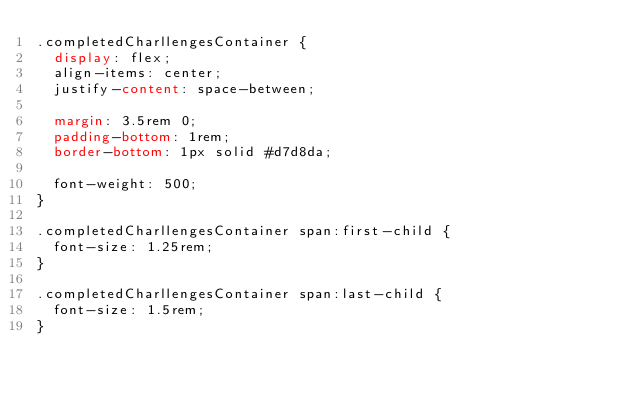Convert code to text. <code><loc_0><loc_0><loc_500><loc_500><_CSS_>.completedCharllengesContainer {
  display: flex;
  align-items: center;
  justify-content: space-between;

  margin: 3.5rem 0;
  padding-bottom: 1rem;
  border-bottom: 1px solid #d7d8da;

  font-weight: 500;
}

.completedCharllengesContainer span:first-child {
  font-size: 1.25rem;
}

.completedCharllengesContainer span:last-child {
  font-size: 1.5rem;
}</code> 